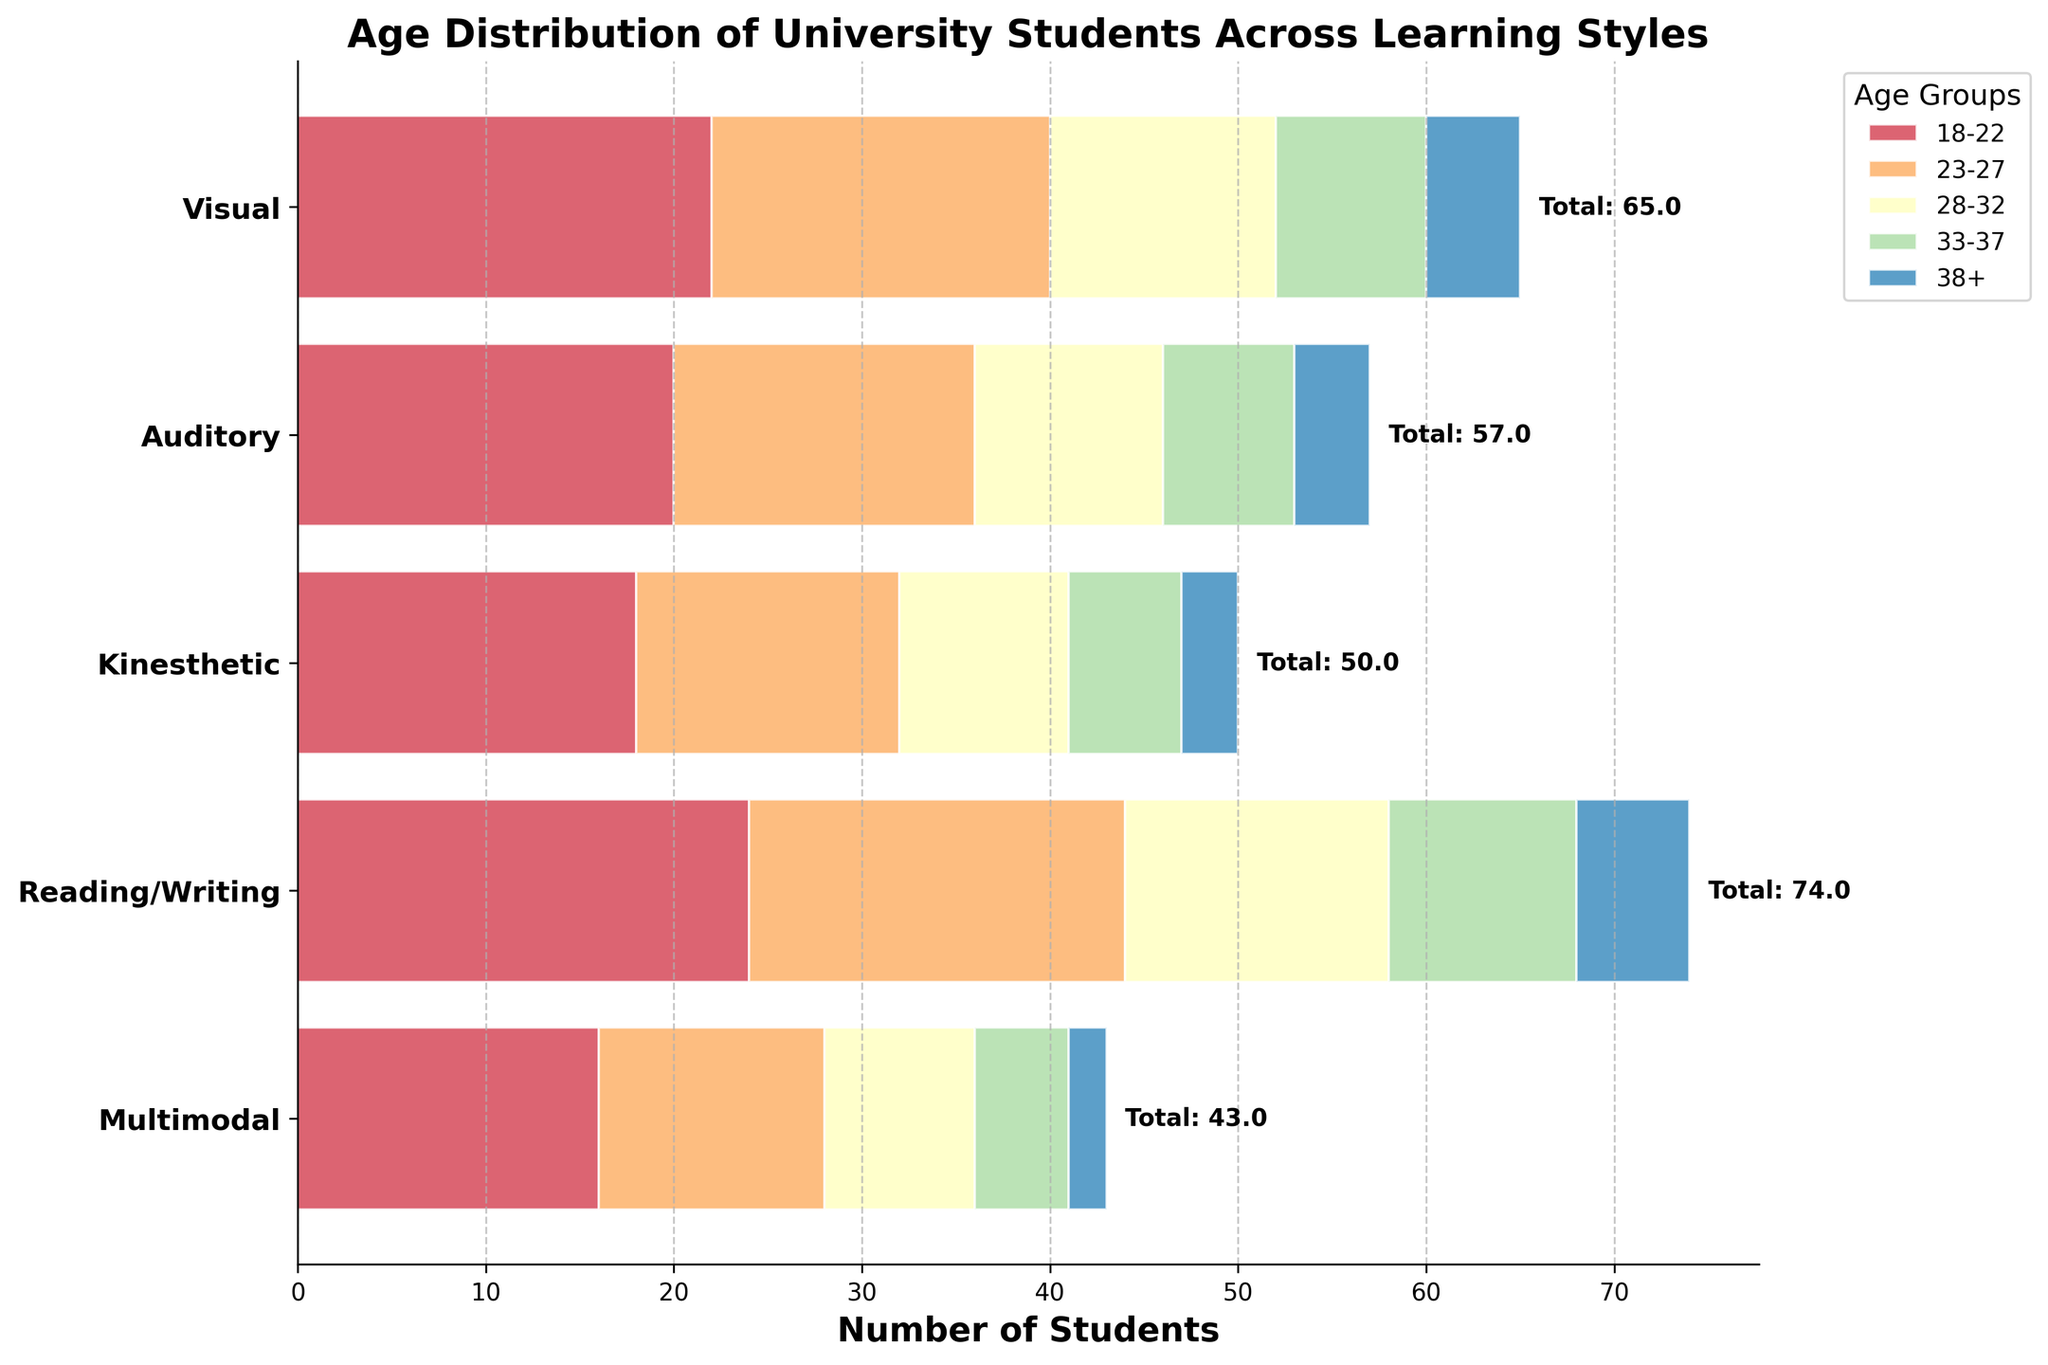Which learning style has the highest total number of students? To find the learning style with the highest total number of students, observe the labels next to the bars indicating the total count. “Reading/Writing” has the highest total of 74 students.
Answer: Reading/Writing What is the age group with the most students within the Visual learning style? Look at the horizontal bar representing the Visual learning style and identify the section with the largest numerical value. The 18-22 age group has the highest count with 22 students.
Answer: 18-22 Are there more students aged 28-32 in the Auditory or Kinesthetic learning style? Compare the values for the 28-32 age group in the Auditory and Kinesthetic learning styles. The Auditory learning style has 10 students, while Kinesthetic has 9. Therefore, Auditory has more students.
Answer: Auditory How many students aged 18-22 are in Kinesthetic and Multimodal learning styles combined? Sum the values from the 18-22 age group for both Kinesthetic (18) and Multimodal (16) learning styles. 18 + 16 equals 34 students in total.
Answer: 34 What's the difference between the number of students aged 33-37 in Reading/Writing and Visual styles? Subtract the number of students aged 33-37 in the Visual style (8) from those in the Reading/Writing style (10). The difference is 2 students.
Answer: 2 Which age group has the smallest representation in the Multimodal learning style? Identify the bar section with the smallest value in the Multimodal learning style. The 38+ age group has the smallest count with 2 students.
Answer: 38+ Compare the number of students aged 23-27 in the Visual and Reading/Writing learning styles. Which learning style has more students in this age group? Compare the values in the 23-27 age group for Visual (18) and Reading/Writing (20). Reading/Writing has more students.
Answer: Reading/Writing What is the average number of students aged 38+ across all learning styles? Sum the values for the 38+ age group across all learning styles and divide by the number of learning styles. (5 from Visual + 4 from Auditory + 3 from Kinesthetic + 6 from Reading/Writing + 2 from Multimodal)/5 = 20/5 = 4.
Answer: 4 Which learning style shows the widest age distribution among its students? Determine the learning style with the most evenly spread student count across different age groups by comparing the bar lengths. Reading/Writing has relatively high and spread-out values among the age groups, indicating a wider distribution.
Answer: Reading/Writing 